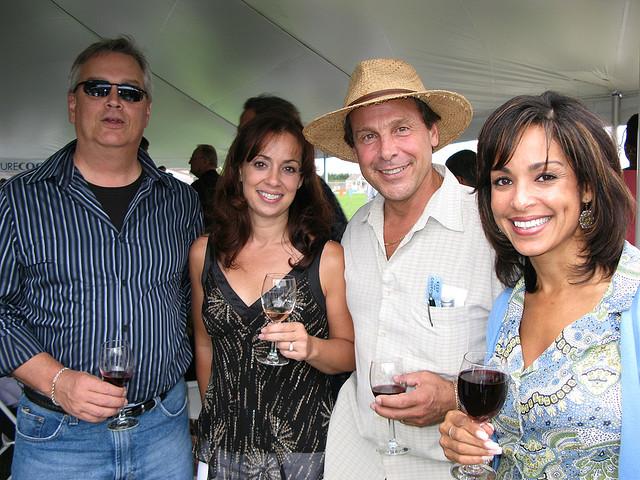Of the four main subjects, how many are wearing sunglasses?
Keep it brief. 1. How many men are in the photo?
Be succinct. 2. Is it midday?
Keep it brief. Yes. 